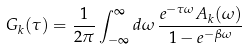<formula> <loc_0><loc_0><loc_500><loc_500>G _ { k } ( \tau ) = \frac { 1 } { 2 \pi } \int _ { - \infty } ^ { \infty } d \omega \, \frac { e ^ { - \tau \omega } A _ { k } ( \omega ) } { 1 - e ^ { - \beta \omega } }</formula> 